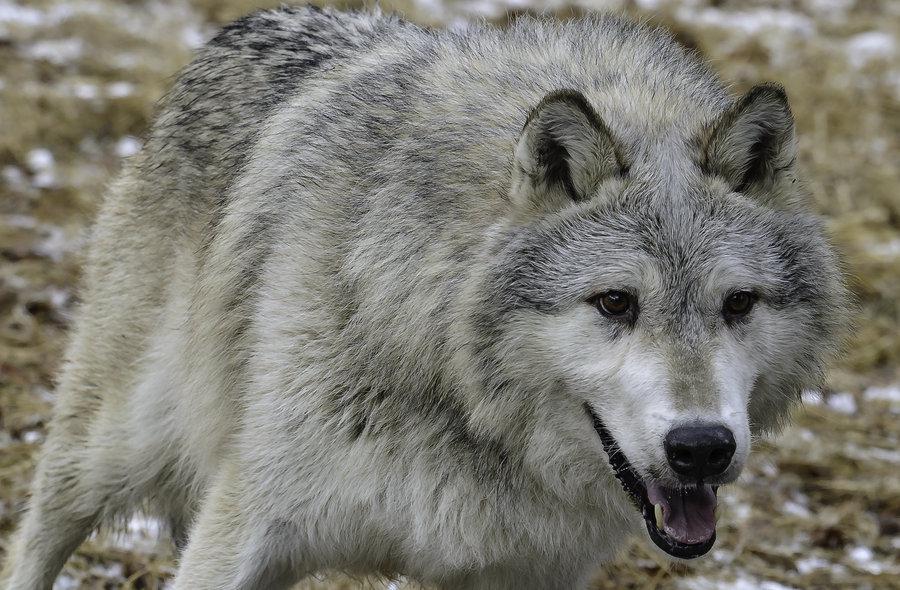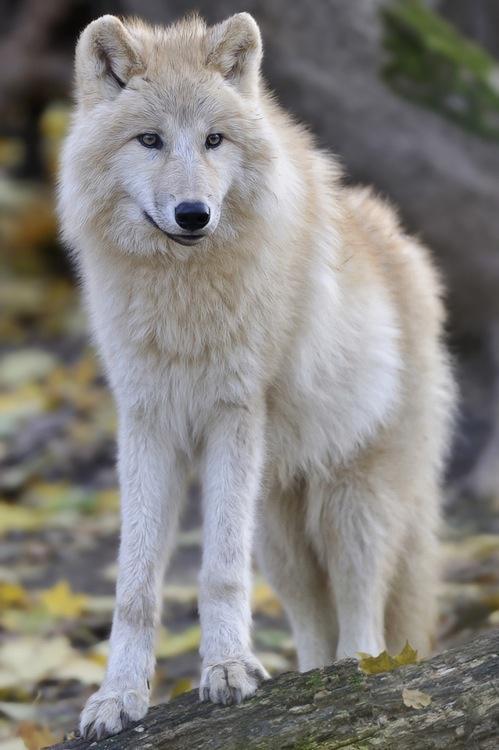The first image is the image on the left, the second image is the image on the right. Assess this claim about the two images: "An animal is laying down.". Correct or not? Answer yes or no. No. The first image is the image on the left, the second image is the image on the right. Evaluate the accuracy of this statement regarding the images: "A canine can be seen laying on the ground.". Is it true? Answer yes or no. No. 